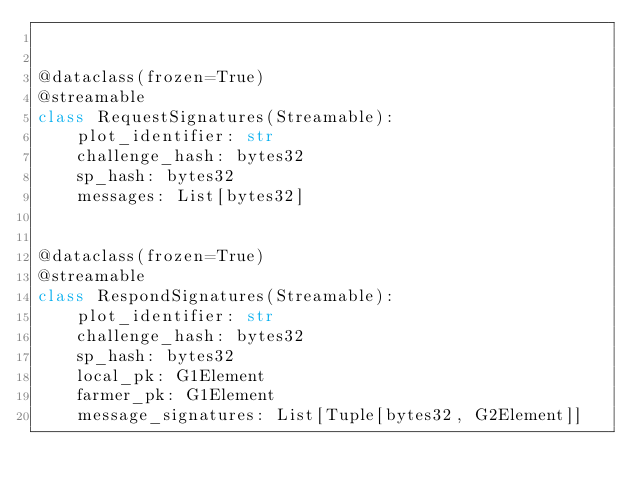<code> <loc_0><loc_0><loc_500><loc_500><_Python_>

@dataclass(frozen=True)
@streamable
class RequestSignatures(Streamable):
    plot_identifier: str
    challenge_hash: bytes32
    sp_hash: bytes32
    messages: List[bytes32]


@dataclass(frozen=True)
@streamable
class RespondSignatures(Streamable):
    plot_identifier: str
    challenge_hash: bytes32
    sp_hash: bytes32
    local_pk: G1Element
    farmer_pk: G1Element
    message_signatures: List[Tuple[bytes32, G2Element]]
</code> 